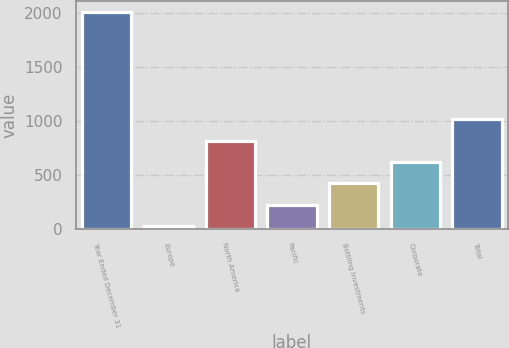Convert chart to OTSL. <chart><loc_0><loc_0><loc_500><loc_500><bar_chart><fcel>Year Ended December 31<fcel>Europe<fcel>North America<fcel>Pacific<fcel>Bottling Investments<fcel>Corporate<fcel>Total<nl><fcel>2011<fcel>25<fcel>819.4<fcel>223.6<fcel>422.2<fcel>620.8<fcel>1018<nl></chart> 